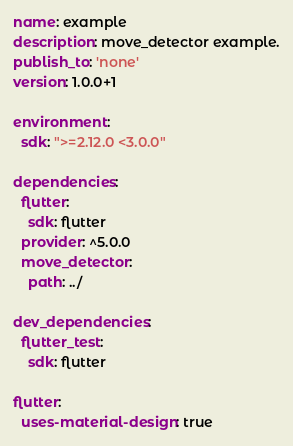<code> <loc_0><loc_0><loc_500><loc_500><_YAML_>name: example
description: move_detector example.
publish_to: 'none'
version: 1.0.0+1

environment:
  sdk: ">=2.12.0 <3.0.0"

dependencies:
  flutter:
    sdk: flutter
  provider: ^5.0.0
  move_detector:
    path: ../

dev_dependencies:
  flutter_test:
    sdk: flutter

flutter:
  uses-material-design: true
</code> 